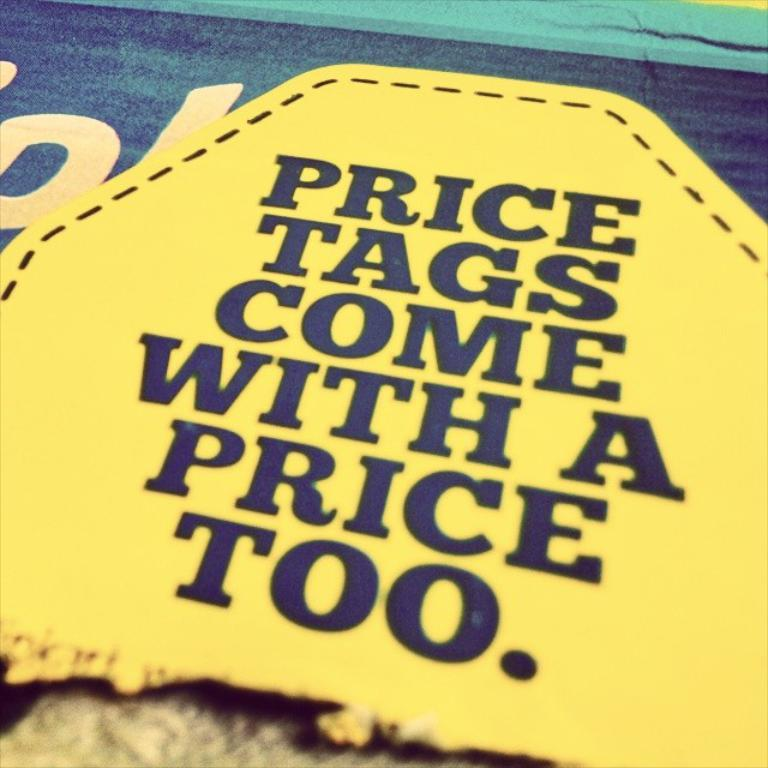<image>
Write a terse but informative summary of the picture. The yellow tag states that  price tags come with a price too. 